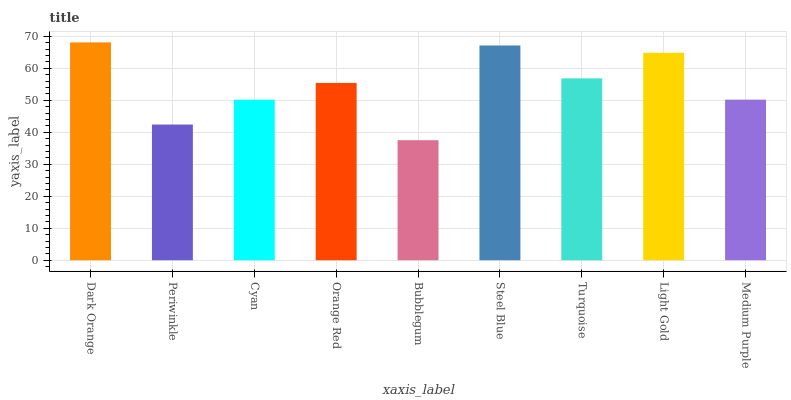Is Bubblegum the minimum?
Answer yes or no. Yes. Is Dark Orange the maximum?
Answer yes or no. Yes. Is Periwinkle the minimum?
Answer yes or no. No. Is Periwinkle the maximum?
Answer yes or no. No. Is Dark Orange greater than Periwinkle?
Answer yes or no. Yes. Is Periwinkle less than Dark Orange?
Answer yes or no. Yes. Is Periwinkle greater than Dark Orange?
Answer yes or no. No. Is Dark Orange less than Periwinkle?
Answer yes or no. No. Is Orange Red the high median?
Answer yes or no. Yes. Is Orange Red the low median?
Answer yes or no. Yes. Is Cyan the high median?
Answer yes or no. No. Is Light Gold the low median?
Answer yes or no. No. 